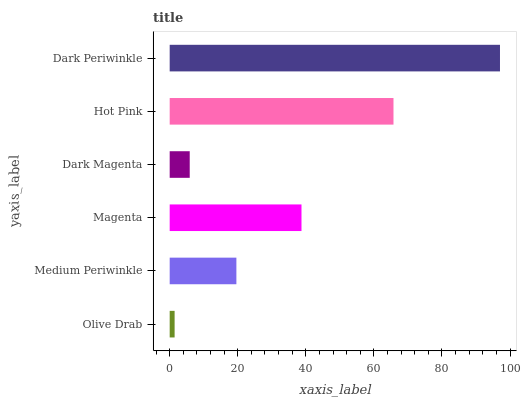Is Olive Drab the minimum?
Answer yes or no. Yes. Is Dark Periwinkle the maximum?
Answer yes or no. Yes. Is Medium Periwinkle the minimum?
Answer yes or no. No. Is Medium Periwinkle the maximum?
Answer yes or no. No. Is Medium Periwinkle greater than Olive Drab?
Answer yes or no. Yes. Is Olive Drab less than Medium Periwinkle?
Answer yes or no. Yes. Is Olive Drab greater than Medium Periwinkle?
Answer yes or no. No. Is Medium Periwinkle less than Olive Drab?
Answer yes or no. No. Is Magenta the high median?
Answer yes or no. Yes. Is Medium Periwinkle the low median?
Answer yes or no. Yes. Is Hot Pink the high median?
Answer yes or no. No. Is Olive Drab the low median?
Answer yes or no. No. 